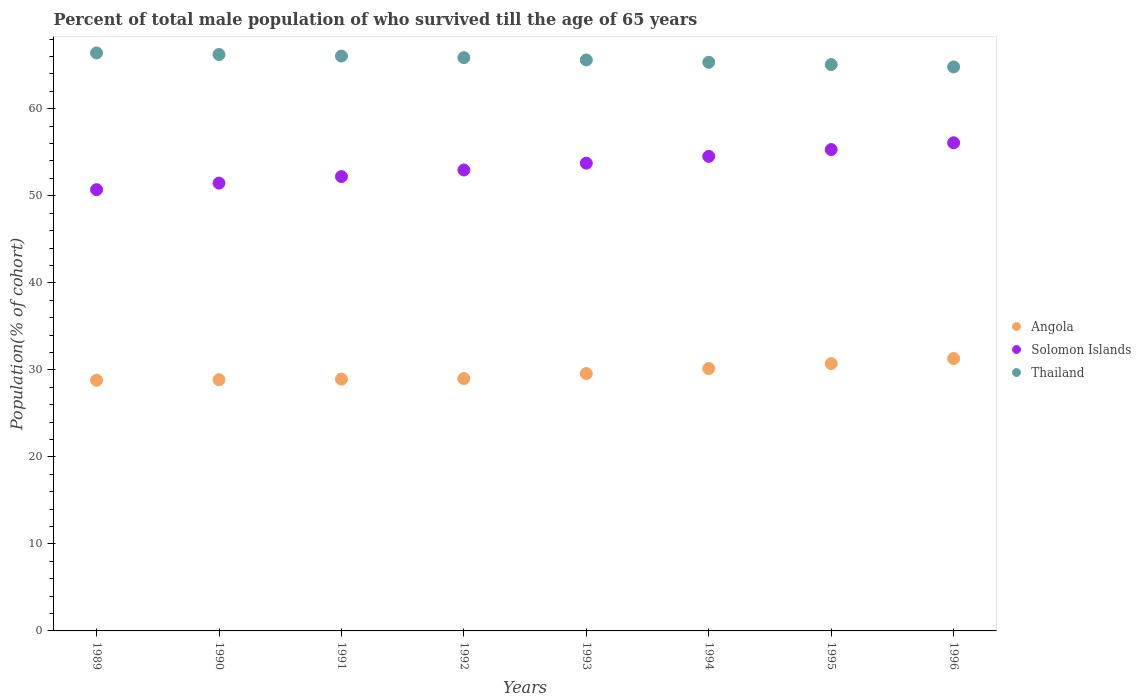Is the number of dotlines equal to the number of legend labels?
Ensure brevity in your answer.  Yes. What is the percentage of total male population who survived till the age of 65 years in Solomon Islands in 1993?
Give a very brief answer. 53.75. Across all years, what is the maximum percentage of total male population who survived till the age of 65 years in Angola?
Give a very brief answer. 31.3. Across all years, what is the minimum percentage of total male population who survived till the age of 65 years in Thailand?
Give a very brief answer. 64.81. In which year was the percentage of total male population who survived till the age of 65 years in Thailand maximum?
Keep it short and to the point. 1989. In which year was the percentage of total male population who survived till the age of 65 years in Thailand minimum?
Provide a succinct answer. 1996. What is the total percentage of total male population who survived till the age of 65 years in Solomon Islands in the graph?
Your answer should be compact. 427.02. What is the difference between the percentage of total male population who survived till the age of 65 years in Angola in 1991 and that in 1994?
Offer a terse response. -1.22. What is the difference between the percentage of total male population who survived till the age of 65 years in Solomon Islands in 1991 and the percentage of total male population who survived till the age of 65 years in Angola in 1996?
Ensure brevity in your answer.  20.91. What is the average percentage of total male population who survived till the age of 65 years in Solomon Islands per year?
Give a very brief answer. 53.38. In the year 1994, what is the difference between the percentage of total male population who survived till the age of 65 years in Thailand and percentage of total male population who survived till the age of 65 years in Angola?
Your response must be concise. 35.19. What is the ratio of the percentage of total male population who survived till the age of 65 years in Angola in 1989 to that in 1990?
Your response must be concise. 1. Is the percentage of total male population who survived till the age of 65 years in Angola in 1989 less than that in 1994?
Ensure brevity in your answer.  Yes. What is the difference between the highest and the second highest percentage of total male population who survived till the age of 65 years in Thailand?
Provide a short and direct response. 0.18. What is the difference between the highest and the lowest percentage of total male population who survived till the age of 65 years in Solomon Islands?
Provide a short and direct response. 5.39. In how many years, is the percentage of total male population who survived till the age of 65 years in Thailand greater than the average percentage of total male population who survived till the age of 65 years in Thailand taken over all years?
Your answer should be compact. 4. Does the percentage of total male population who survived till the age of 65 years in Solomon Islands monotonically increase over the years?
Keep it short and to the point. Yes. Is the percentage of total male population who survived till the age of 65 years in Angola strictly greater than the percentage of total male population who survived till the age of 65 years in Solomon Islands over the years?
Provide a succinct answer. No. What is the difference between two consecutive major ticks on the Y-axis?
Your response must be concise. 10. Does the graph contain any zero values?
Offer a terse response. No. Where does the legend appear in the graph?
Provide a short and direct response. Center right. How are the legend labels stacked?
Keep it short and to the point. Vertical. What is the title of the graph?
Your answer should be very brief. Percent of total male population of who survived till the age of 65 years. Does "Liechtenstein" appear as one of the legend labels in the graph?
Your response must be concise. No. What is the label or title of the X-axis?
Provide a short and direct response. Years. What is the label or title of the Y-axis?
Provide a short and direct response. Population(% of cohort). What is the Population(% of cohort) in Angola in 1989?
Your response must be concise. 28.81. What is the Population(% of cohort) of Solomon Islands in 1989?
Your response must be concise. 50.7. What is the Population(% of cohort) of Thailand in 1989?
Offer a very short reply. 66.41. What is the Population(% of cohort) in Angola in 1990?
Your response must be concise. 28.87. What is the Population(% of cohort) in Solomon Islands in 1990?
Offer a terse response. 51.46. What is the Population(% of cohort) in Thailand in 1990?
Offer a terse response. 66.23. What is the Population(% of cohort) in Angola in 1991?
Your answer should be compact. 28.93. What is the Population(% of cohort) in Solomon Islands in 1991?
Offer a very short reply. 52.21. What is the Population(% of cohort) in Thailand in 1991?
Your answer should be compact. 66.06. What is the Population(% of cohort) in Angola in 1992?
Your answer should be compact. 29. What is the Population(% of cohort) in Solomon Islands in 1992?
Give a very brief answer. 52.97. What is the Population(% of cohort) of Thailand in 1992?
Provide a succinct answer. 65.88. What is the Population(% of cohort) in Angola in 1993?
Keep it short and to the point. 29.57. What is the Population(% of cohort) of Solomon Islands in 1993?
Your answer should be compact. 53.75. What is the Population(% of cohort) of Thailand in 1993?
Offer a terse response. 65.61. What is the Population(% of cohort) of Angola in 1994?
Ensure brevity in your answer.  30.15. What is the Population(% of cohort) of Solomon Islands in 1994?
Provide a short and direct response. 54.53. What is the Population(% of cohort) in Thailand in 1994?
Give a very brief answer. 65.34. What is the Population(% of cohort) in Angola in 1995?
Give a very brief answer. 30.72. What is the Population(% of cohort) in Solomon Islands in 1995?
Provide a succinct answer. 55.31. What is the Population(% of cohort) of Thailand in 1995?
Keep it short and to the point. 65.07. What is the Population(% of cohort) in Angola in 1996?
Make the answer very short. 31.3. What is the Population(% of cohort) in Solomon Islands in 1996?
Your answer should be compact. 56.09. What is the Population(% of cohort) of Thailand in 1996?
Ensure brevity in your answer.  64.81. Across all years, what is the maximum Population(% of cohort) of Angola?
Your answer should be compact. 31.3. Across all years, what is the maximum Population(% of cohort) of Solomon Islands?
Your answer should be compact. 56.09. Across all years, what is the maximum Population(% of cohort) of Thailand?
Offer a very short reply. 66.41. Across all years, what is the minimum Population(% of cohort) of Angola?
Provide a succinct answer. 28.81. Across all years, what is the minimum Population(% of cohort) in Solomon Islands?
Offer a terse response. 50.7. Across all years, what is the minimum Population(% of cohort) of Thailand?
Keep it short and to the point. 64.81. What is the total Population(% of cohort) of Angola in the graph?
Ensure brevity in your answer.  237.35. What is the total Population(% of cohort) of Solomon Islands in the graph?
Your response must be concise. 427.02. What is the total Population(% of cohort) of Thailand in the graph?
Make the answer very short. 525.41. What is the difference between the Population(% of cohort) of Angola in 1989 and that in 1990?
Offer a terse response. -0.06. What is the difference between the Population(% of cohort) of Solomon Islands in 1989 and that in 1990?
Make the answer very short. -0.75. What is the difference between the Population(% of cohort) of Thailand in 1989 and that in 1990?
Ensure brevity in your answer.  0.18. What is the difference between the Population(% of cohort) in Angola in 1989 and that in 1991?
Give a very brief answer. -0.13. What is the difference between the Population(% of cohort) of Solomon Islands in 1989 and that in 1991?
Ensure brevity in your answer.  -1.51. What is the difference between the Population(% of cohort) of Thailand in 1989 and that in 1991?
Ensure brevity in your answer.  0.36. What is the difference between the Population(% of cohort) in Angola in 1989 and that in 1992?
Make the answer very short. -0.19. What is the difference between the Population(% of cohort) in Solomon Islands in 1989 and that in 1992?
Offer a very short reply. -2.26. What is the difference between the Population(% of cohort) in Thailand in 1989 and that in 1992?
Your answer should be very brief. 0.54. What is the difference between the Population(% of cohort) of Angola in 1989 and that in 1993?
Make the answer very short. -0.77. What is the difference between the Population(% of cohort) in Solomon Islands in 1989 and that in 1993?
Your answer should be very brief. -3.05. What is the difference between the Population(% of cohort) in Thailand in 1989 and that in 1993?
Offer a very short reply. 0.81. What is the difference between the Population(% of cohort) in Angola in 1989 and that in 1994?
Your response must be concise. -1.34. What is the difference between the Population(% of cohort) of Solomon Islands in 1989 and that in 1994?
Your answer should be very brief. -3.83. What is the difference between the Population(% of cohort) in Thailand in 1989 and that in 1994?
Provide a short and direct response. 1.07. What is the difference between the Population(% of cohort) of Angola in 1989 and that in 1995?
Your answer should be very brief. -1.92. What is the difference between the Population(% of cohort) in Solomon Islands in 1989 and that in 1995?
Offer a terse response. -4.61. What is the difference between the Population(% of cohort) in Thailand in 1989 and that in 1995?
Your response must be concise. 1.34. What is the difference between the Population(% of cohort) of Angola in 1989 and that in 1996?
Keep it short and to the point. -2.5. What is the difference between the Population(% of cohort) of Solomon Islands in 1989 and that in 1996?
Your response must be concise. -5.39. What is the difference between the Population(% of cohort) of Thailand in 1989 and that in 1996?
Give a very brief answer. 1.61. What is the difference between the Population(% of cohort) in Angola in 1990 and that in 1991?
Offer a terse response. -0.06. What is the difference between the Population(% of cohort) of Solomon Islands in 1990 and that in 1991?
Your answer should be very brief. -0.75. What is the difference between the Population(% of cohort) of Thailand in 1990 and that in 1991?
Provide a succinct answer. 0.18. What is the difference between the Population(% of cohort) of Angola in 1990 and that in 1992?
Provide a short and direct response. -0.13. What is the difference between the Population(% of cohort) in Solomon Islands in 1990 and that in 1992?
Give a very brief answer. -1.51. What is the difference between the Population(% of cohort) of Thailand in 1990 and that in 1992?
Your answer should be very brief. 0.36. What is the difference between the Population(% of cohort) of Angola in 1990 and that in 1993?
Ensure brevity in your answer.  -0.7. What is the difference between the Population(% of cohort) of Solomon Islands in 1990 and that in 1993?
Provide a succinct answer. -2.29. What is the difference between the Population(% of cohort) in Thailand in 1990 and that in 1993?
Provide a succinct answer. 0.63. What is the difference between the Population(% of cohort) in Angola in 1990 and that in 1994?
Ensure brevity in your answer.  -1.28. What is the difference between the Population(% of cohort) of Solomon Islands in 1990 and that in 1994?
Your answer should be compact. -3.07. What is the difference between the Population(% of cohort) of Thailand in 1990 and that in 1994?
Give a very brief answer. 0.89. What is the difference between the Population(% of cohort) of Angola in 1990 and that in 1995?
Offer a very short reply. -1.86. What is the difference between the Population(% of cohort) of Solomon Islands in 1990 and that in 1995?
Make the answer very short. -3.85. What is the difference between the Population(% of cohort) in Thailand in 1990 and that in 1995?
Your answer should be compact. 1.16. What is the difference between the Population(% of cohort) of Angola in 1990 and that in 1996?
Your answer should be very brief. -2.43. What is the difference between the Population(% of cohort) of Solomon Islands in 1990 and that in 1996?
Ensure brevity in your answer.  -4.64. What is the difference between the Population(% of cohort) of Thailand in 1990 and that in 1996?
Give a very brief answer. 1.43. What is the difference between the Population(% of cohort) of Angola in 1991 and that in 1992?
Offer a very short reply. -0.06. What is the difference between the Population(% of cohort) of Solomon Islands in 1991 and that in 1992?
Keep it short and to the point. -0.75. What is the difference between the Population(% of cohort) in Thailand in 1991 and that in 1992?
Offer a very short reply. 0.18. What is the difference between the Population(% of cohort) of Angola in 1991 and that in 1993?
Your response must be concise. -0.64. What is the difference between the Population(% of cohort) of Solomon Islands in 1991 and that in 1993?
Make the answer very short. -1.54. What is the difference between the Population(% of cohort) in Thailand in 1991 and that in 1993?
Your answer should be very brief. 0.45. What is the difference between the Population(% of cohort) of Angola in 1991 and that in 1994?
Your answer should be very brief. -1.22. What is the difference between the Population(% of cohort) in Solomon Islands in 1991 and that in 1994?
Make the answer very short. -2.32. What is the difference between the Population(% of cohort) of Thailand in 1991 and that in 1994?
Your answer should be compact. 0.71. What is the difference between the Population(% of cohort) of Angola in 1991 and that in 1995?
Your answer should be very brief. -1.79. What is the difference between the Population(% of cohort) in Solomon Islands in 1991 and that in 1995?
Give a very brief answer. -3.1. What is the difference between the Population(% of cohort) in Thailand in 1991 and that in 1995?
Keep it short and to the point. 0.98. What is the difference between the Population(% of cohort) of Angola in 1991 and that in 1996?
Provide a short and direct response. -2.37. What is the difference between the Population(% of cohort) in Solomon Islands in 1991 and that in 1996?
Your response must be concise. -3.88. What is the difference between the Population(% of cohort) in Thailand in 1991 and that in 1996?
Make the answer very short. 1.25. What is the difference between the Population(% of cohort) of Angola in 1992 and that in 1993?
Provide a short and direct response. -0.58. What is the difference between the Population(% of cohort) in Solomon Islands in 1992 and that in 1993?
Offer a very short reply. -0.78. What is the difference between the Population(% of cohort) in Thailand in 1992 and that in 1993?
Keep it short and to the point. 0.27. What is the difference between the Population(% of cohort) in Angola in 1992 and that in 1994?
Make the answer very short. -1.15. What is the difference between the Population(% of cohort) in Solomon Islands in 1992 and that in 1994?
Offer a very short reply. -1.56. What is the difference between the Population(% of cohort) in Thailand in 1992 and that in 1994?
Provide a succinct answer. 0.53. What is the difference between the Population(% of cohort) in Angola in 1992 and that in 1995?
Provide a short and direct response. -1.73. What is the difference between the Population(% of cohort) in Solomon Islands in 1992 and that in 1995?
Make the answer very short. -2.35. What is the difference between the Population(% of cohort) of Thailand in 1992 and that in 1995?
Keep it short and to the point. 0.8. What is the difference between the Population(% of cohort) of Angola in 1992 and that in 1996?
Your response must be concise. -2.31. What is the difference between the Population(% of cohort) in Solomon Islands in 1992 and that in 1996?
Keep it short and to the point. -3.13. What is the difference between the Population(% of cohort) in Thailand in 1992 and that in 1996?
Give a very brief answer. 1.07. What is the difference between the Population(% of cohort) of Angola in 1993 and that in 1994?
Offer a very short reply. -0.58. What is the difference between the Population(% of cohort) of Solomon Islands in 1993 and that in 1994?
Give a very brief answer. -0.78. What is the difference between the Population(% of cohort) in Thailand in 1993 and that in 1994?
Give a very brief answer. 0.27. What is the difference between the Population(% of cohort) in Angola in 1993 and that in 1995?
Offer a terse response. -1.15. What is the difference between the Population(% of cohort) of Solomon Islands in 1993 and that in 1995?
Ensure brevity in your answer.  -1.56. What is the difference between the Population(% of cohort) in Thailand in 1993 and that in 1995?
Provide a succinct answer. 0.53. What is the difference between the Population(% of cohort) in Angola in 1993 and that in 1996?
Provide a short and direct response. -1.73. What is the difference between the Population(% of cohort) of Solomon Islands in 1993 and that in 1996?
Provide a succinct answer. -2.35. What is the difference between the Population(% of cohort) in Thailand in 1993 and that in 1996?
Give a very brief answer. 0.8. What is the difference between the Population(% of cohort) in Angola in 1994 and that in 1995?
Give a very brief answer. -0.58. What is the difference between the Population(% of cohort) in Solomon Islands in 1994 and that in 1995?
Offer a very short reply. -0.78. What is the difference between the Population(% of cohort) of Thailand in 1994 and that in 1995?
Ensure brevity in your answer.  0.27. What is the difference between the Population(% of cohort) in Angola in 1994 and that in 1996?
Make the answer very short. -1.15. What is the difference between the Population(% of cohort) in Solomon Islands in 1994 and that in 1996?
Provide a succinct answer. -1.56. What is the difference between the Population(% of cohort) in Thailand in 1994 and that in 1996?
Keep it short and to the point. 0.53. What is the difference between the Population(% of cohort) in Angola in 1995 and that in 1996?
Keep it short and to the point. -0.58. What is the difference between the Population(% of cohort) in Solomon Islands in 1995 and that in 1996?
Make the answer very short. -0.78. What is the difference between the Population(% of cohort) in Thailand in 1995 and that in 1996?
Keep it short and to the point. 0.27. What is the difference between the Population(% of cohort) in Angola in 1989 and the Population(% of cohort) in Solomon Islands in 1990?
Your answer should be compact. -22.65. What is the difference between the Population(% of cohort) of Angola in 1989 and the Population(% of cohort) of Thailand in 1990?
Your response must be concise. -37.43. What is the difference between the Population(% of cohort) of Solomon Islands in 1989 and the Population(% of cohort) of Thailand in 1990?
Your answer should be very brief. -15.53. What is the difference between the Population(% of cohort) of Angola in 1989 and the Population(% of cohort) of Solomon Islands in 1991?
Your answer should be very brief. -23.41. What is the difference between the Population(% of cohort) in Angola in 1989 and the Population(% of cohort) in Thailand in 1991?
Make the answer very short. -37.25. What is the difference between the Population(% of cohort) in Solomon Islands in 1989 and the Population(% of cohort) in Thailand in 1991?
Provide a short and direct response. -15.35. What is the difference between the Population(% of cohort) in Angola in 1989 and the Population(% of cohort) in Solomon Islands in 1992?
Offer a terse response. -24.16. What is the difference between the Population(% of cohort) of Angola in 1989 and the Population(% of cohort) of Thailand in 1992?
Offer a very short reply. -37.07. What is the difference between the Population(% of cohort) in Solomon Islands in 1989 and the Population(% of cohort) in Thailand in 1992?
Make the answer very short. -15.17. What is the difference between the Population(% of cohort) in Angola in 1989 and the Population(% of cohort) in Solomon Islands in 1993?
Give a very brief answer. -24.94. What is the difference between the Population(% of cohort) of Angola in 1989 and the Population(% of cohort) of Thailand in 1993?
Provide a succinct answer. -36.8. What is the difference between the Population(% of cohort) of Solomon Islands in 1989 and the Population(% of cohort) of Thailand in 1993?
Your answer should be very brief. -14.91. What is the difference between the Population(% of cohort) in Angola in 1989 and the Population(% of cohort) in Solomon Islands in 1994?
Provide a short and direct response. -25.72. What is the difference between the Population(% of cohort) of Angola in 1989 and the Population(% of cohort) of Thailand in 1994?
Offer a very short reply. -36.54. What is the difference between the Population(% of cohort) of Solomon Islands in 1989 and the Population(% of cohort) of Thailand in 1994?
Offer a terse response. -14.64. What is the difference between the Population(% of cohort) of Angola in 1989 and the Population(% of cohort) of Solomon Islands in 1995?
Give a very brief answer. -26.51. What is the difference between the Population(% of cohort) in Angola in 1989 and the Population(% of cohort) in Thailand in 1995?
Your response must be concise. -36.27. What is the difference between the Population(% of cohort) of Solomon Islands in 1989 and the Population(% of cohort) of Thailand in 1995?
Your answer should be compact. -14.37. What is the difference between the Population(% of cohort) of Angola in 1989 and the Population(% of cohort) of Solomon Islands in 1996?
Your response must be concise. -27.29. What is the difference between the Population(% of cohort) of Angola in 1989 and the Population(% of cohort) of Thailand in 1996?
Ensure brevity in your answer.  -36. What is the difference between the Population(% of cohort) in Solomon Islands in 1989 and the Population(% of cohort) in Thailand in 1996?
Your answer should be very brief. -14.1. What is the difference between the Population(% of cohort) of Angola in 1990 and the Population(% of cohort) of Solomon Islands in 1991?
Offer a very short reply. -23.34. What is the difference between the Population(% of cohort) in Angola in 1990 and the Population(% of cohort) in Thailand in 1991?
Provide a succinct answer. -37.19. What is the difference between the Population(% of cohort) in Solomon Islands in 1990 and the Population(% of cohort) in Thailand in 1991?
Offer a terse response. -14.6. What is the difference between the Population(% of cohort) of Angola in 1990 and the Population(% of cohort) of Solomon Islands in 1992?
Your response must be concise. -24.1. What is the difference between the Population(% of cohort) in Angola in 1990 and the Population(% of cohort) in Thailand in 1992?
Your answer should be very brief. -37.01. What is the difference between the Population(% of cohort) of Solomon Islands in 1990 and the Population(% of cohort) of Thailand in 1992?
Your response must be concise. -14.42. What is the difference between the Population(% of cohort) in Angola in 1990 and the Population(% of cohort) in Solomon Islands in 1993?
Give a very brief answer. -24.88. What is the difference between the Population(% of cohort) in Angola in 1990 and the Population(% of cohort) in Thailand in 1993?
Keep it short and to the point. -36.74. What is the difference between the Population(% of cohort) in Solomon Islands in 1990 and the Population(% of cohort) in Thailand in 1993?
Your response must be concise. -14.15. What is the difference between the Population(% of cohort) of Angola in 1990 and the Population(% of cohort) of Solomon Islands in 1994?
Provide a succinct answer. -25.66. What is the difference between the Population(% of cohort) of Angola in 1990 and the Population(% of cohort) of Thailand in 1994?
Give a very brief answer. -36.47. What is the difference between the Population(% of cohort) of Solomon Islands in 1990 and the Population(% of cohort) of Thailand in 1994?
Provide a short and direct response. -13.88. What is the difference between the Population(% of cohort) of Angola in 1990 and the Population(% of cohort) of Solomon Islands in 1995?
Your answer should be compact. -26.44. What is the difference between the Population(% of cohort) of Angola in 1990 and the Population(% of cohort) of Thailand in 1995?
Give a very brief answer. -36.21. What is the difference between the Population(% of cohort) in Solomon Islands in 1990 and the Population(% of cohort) in Thailand in 1995?
Provide a short and direct response. -13.62. What is the difference between the Population(% of cohort) in Angola in 1990 and the Population(% of cohort) in Solomon Islands in 1996?
Keep it short and to the point. -27.22. What is the difference between the Population(% of cohort) of Angola in 1990 and the Population(% of cohort) of Thailand in 1996?
Keep it short and to the point. -35.94. What is the difference between the Population(% of cohort) in Solomon Islands in 1990 and the Population(% of cohort) in Thailand in 1996?
Offer a terse response. -13.35. What is the difference between the Population(% of cohort) in Angola in 1991 and the Population(% of cohort) in Solomon Islands in 1992?
Your response must be concise. -24.03. What is the difference between the Population(% of cohort) in Angola in 1991 and the Population(% of cohort) in Thailand in 1992?
Provide a succinct answer. -36.94. What is the difference between the Population(% of cohort) in Solomon Islands in 1991 and the Population(% of cohort) in Thailand in 1992?
Keep it short and to the point. -13.66. What is the difference between the Population(% of cohort) of Angola in 1991 and the Population(% of cohort) of Solomon Islands in 1993?
Give a very brief answer. -24.82. What is the difference between the Population(% of cohort) in Angola in 1991 and the Population(% of cohort) in Thailand in 1993?
Give a very brief answer. -36.68. What is the difference between the Population(% of cohort) of Solomon Islands in 1991 and the Population(% of cohort) of Thailand in 1993?
Offer a terse response. -13.4. What is the difference between the Population(% of cohort) in Angola in 1991 and the Population(% of cohort) in Solomon Islands in 1994?
Your answer should be compact. -25.6. What is the difference between the Population(% of cohort) of Angola in 1991 and the Population(% of cohort) of Thailand in 1994?
Make the answer very short. -36.41. What is the difference between the Population(% of cohort) of Solomon Islands in 1991 and the Population(% of cohort) of Thailand in 1994?
Ensure brevity in your answer.  -13.13. What is the difference between the Population(% of cohort) of Angola in 1991 and the Population(% of cohort) of Solomon Islands in 1995?
Make the answer very short. -26.38. What is the difference between the Population(% of cohort) in Angola in 1991 and the Population(% of cohort) in Thailand in 1995?
Your answer should be compact. -36.14. What is the difference between the Population(% of cohort) of Solomon Islands in 1991 and the Population(% of cohort) of Thailand in 1995?
Your response must be concise. -12.86. What is the difference between the Population(% of cohort) in Angola in 1991 and the Population(% of cohort) in Solomon Islands in 1996?
Your response must be concise. -27.16. What is the difference between the Population(% of cohort) of Angola in 1991 and the Population(% of cohort) of Thailand in 1996?
Provide a short and direct response. -35.87. What is the difference between the Population(% of cohort) of Solomon Islands in 1991 and the Population(% of cohort) of Thailand in 1996?
Your answer should be very brief. -12.6. What is the difference between the Population(% of cohort) of Angola in 1992 and the Population(% of cohort) of Solomon Islands in 1993?
Ensure brevity in your answer.  -24.75. What is the difference between the Population(% of cohort) in Angola in 1992 and the Population(% of cohort) in Thailand in 1993?
Your answer should be compact. -36.61. What is the difference between the Population(% of cohort) of Solomon Islands in 1992 and the Population(% of cohort) of Thailand in 1993?
Offer a terse response. -12.64. What is the difference between the Population(% of cohort) of Angola in 1992 and the Population(% of cohort) of Solomon Islands in 1994?
Your response must be concise. -25.53. What is the difference between the Population(% of cohort) of Angola in 1992 and the Population(% of cohort) of Thailand in 1994?
Give a very brief answer. -36.35. What is the difference between the Population(% of cohort) of Solomon Islands in 1992 and the Population(% of cohort) of Thailand in 1994?
Your answer should be very brief. -12.38. What is the difference between the Population(% of cohort) of Angola in 1992 and the Population(% of cohort) of Solomon Islands in 1995?
Provide a succinct answer. -26.32. What is the difference between the Population(% of cohort) of Angola in 1992 and the Population(% of cohort) of Thailand in 1995?
Your answer should be very brief. -36.08. What is the difference between the Population(% of cohort) in Solomon Islands in 1992 and the Population(% of cohort) in Thailand in 1995?
Provide a succinct answer. -12.11. What is the difference between the Population(% of cohort) in Angola in 1992 and the Population(% of cohort) in Solomon Islands in 1996?
Offer a terse response. -27.1. What is the difference between the Population(% of cohort) of Angola in 1992 and the Population(% of cohort) of Thailand in 1996?
Your response must be concise. -35.81. What is the difference between the Population(% of cohort) of Solomon Islands in 1992 and the Population(% of cohort) of Thailand in 1996?
Offer a terse response. -11.84. What is the difference between the Population(% of cohort) of Angola in 1993 and the Population(% of cohort) of Solomon Islands in 1994?
Give a very brief answer. -24.96. What is the difference between the Population(% of cohort) of Angola in 1993 and the Population(% of cohort) of Thailand in 1994?
Provide a short and direct response. -35.77. What is the difference between the Population(% of cohort) of Solomon Islands in 1993 and the Population(% of cohort) of Thailand in 1994?
Keep it short and to the point. -11.59. What is the difference between the Population(% of cohort) in Angola in 1993 and the Population(% of cohort) in Solomon Islands in 1995?
Your answer should be very brief. -25.74. What is the difference between the Population(% of cohort) in Angola in 1993 and the Population(% of cohort) in Thailand in 1995?
Make the answer very short. -35.5. What is the difference between the Population(% of cohort) of Solomon Islands in 1993 and the Population(% of cohort) of Thailand in 1995?
Keep it short and to the point. -11.33. What is the difference between the Population(% of cohort) of Angola in 1993 and the Population(% of cohort) of Solomon Islands in 1996?
Make the answer very short. -26.52. What is the difference between the Population(% of cohort) of Angola in 1993 and the Population(% of cohort) of Thailand in 1996?
Provide a short and direct response. -35.24. What is the difference between the Population(% of cohort) in Solomon Islands in 1993 and the Population(% of cohort) in Thailand in 1996?
Provide a short and direct response. -11.06. What is the difference between the Population(% of cohort) of Angola in 1994 and the Population(% of cohort) of Solomon Islands in 1995?
Your response must be concise. -25.16. What is the difference between the Population(% of cohort) of Angola in 1994 and the Population(% of cohort) of Thailand in 1995?
Offer a very short reply. -34.93. What is the difference between the Population(% of cohort) in Solomon Islands in 1994 and the Population(% of cohort) in Thailand in 1995?
Provide a succinct answer. -10.54. What is the difference between the Population(% of cohort) of Angola in 1994 and the Population(% of cohort) of Solomon Islands in 1996?
Your answer should be compact. -25.94. What is the difference between the Population(% of cohort) of Angola in 1994 and the Population(% of cohort) of Thailand in 1996?
Ensure brevity in your answer.  -34.66. What is the difference between the Population(% of cohort) in Solomon Islands in 1994 and the Population(% of cohort) in Thailand in 1996?
Offer a very short reply. -10.28. What is the difference between the Population(% of cohort) in Angola in 1995 and the Population(% of cohort) in Solomon Islands in 1996?
Offer a terse response. -25.37. What is the difference between the Population(% of cohort) in Angola in 1995 and the Population(% of cohort) in Thailand in 1996?
Offer a very short reply. -34.08. What is the difference between the Population(% of cohort) of Solomon Islands in 1995 and the Population(% of cohort) of Thailand in 1996?
Your answer should be compact. -9.5. What is the average Population(% of cohort) in Angola per year?
Offer a terse response. 29.67. What is the average Population(% of cohort) in Solomon Islands per year?
Offer a very short reply. 53.38. What is the average Population(% of cohort) in Thailand per year?
Your response must be concise. 65.68. In the year 1989, what is the difference between the Population(% of cohort) in Angola and Population(% of cohort) in Solomon Islands?
Give a very brief answer. -21.9. In the year 1989, what is the difference between the Population(% of cohort) in Angola and Population(% of cohort) in Thailand?
Ensure brevity in your answer.  -37.61. In the year 1989, what is the difference between the Population(% of cohort) of Solomon Islands and Population(% of cohort) of Thailand?
Ensure brevity in your answer.  -15.71. In the year 1990, what is the difference between the Population(% of cohort) in Angola and Population(% of cohort) in Solomon Islands?
Provide a succinct answer. -22.59. In the year 1990, what is the difference between the Population(% of cohort) in Angola and Population(% of cohort) in Thailand?
Your response must be concise. -37.37. In the year 1990, what is the difference between the Population(% of cohort) of Solomon Islands and Population(% of cohort) of Thailand?
Provide a short and direct response. -14.78. In the year 1991, what is the difference between the Population(% of cohort) in Angola and Population(% of cohort) in Solomon Islands?
Offer a terse response. -23.28. In the year 1991, what is the difference between the Population(% of cohort) of Angola and Population(% of cohort) of Thailand?
Give a very brief answer. -37.12. In the year 1991, what is the difference between the Population(% of cohort) of Solomon Islands and Population(% of cohort) of Thailand?
Ensure brevity in your answer.  -13.84. In the year 1992, what is the difference between the Population(% of cohort) of Angola and Population(% of cohort) of Solomon Islands?
Make the answer very short. -23.97. In the year 1992, what is the difference between the Population(% of cohort) of Angola and Population(% of cohort) of Thailand?
Your answer should be very brief. -36.88. In the year 1992, what is the difference between the Population(% of cohort) in Solomon Islands and Population(% of cohort) in Thailand?
Ensure brevity in your answer.  -12.91. In the year 1993, what is the difference between the Population(% of cohort) in Angola and Population(% of cohort) in Solomon Islands?
Your response must be concise. -24.18. In the year 1993, what is the difference between the Population(% of cohort) in Angola and Population(% of cohort) in Thailand?
Keep it short and to the point. -36.04. In the year 1993, what is the difference between the Population(% of cohort) of Solomon Islands and Population(% of cohort) of Thailand?
Give a very brief answer. -11.86. In the year 1994, what is the difference between the Population(% of cohort) of Angola and Population(% of cohort) of Solomon Islands?
Give a very brief answer. -24.38. In the year 1994, what is the difference between the Population(% of cohort) in Angola and Population(% of cohort) in Thailand?
Your answer should be compact. -35.19. In the year 1994, what is the difference between the Population(% of cohort) in Solomon Islands and Population(% of cohort) in Thailand?
Ensure brevity in your answer.  -10.81. In the year 1995, what is the difference between the Population(% of cohort) in Angola and Population(% of cohort) in Solomon Islands?
Make the answer very short. -24.59. In the year 1995, what is the difference between the Population(% of cohort) of Angola and Population(% of cohort) of Thailand?
Offer a terse response. -34.35. In the year 1995, what is the difference between the Population(% of cohort) of Solomon Islands and Population(% of cohort) of Thailand?
Give a very brief answer. -9.76. In the year 1996, what is the difference between the Population(% of cohort) in Angola and Population(% of cohort) in Solomon Islands?
Ensure brevity in your answer.  -24.79. In the year 1996, what is the difference between the Population(% of cohort) in Angola and Population(% of cohort) in Thailand?
Ensure brevity in your answer.  -33.51. In the year 1996, what is the difference between the Population(% of cohort) in Solomon Islands and Population(% of cohort) in Thailand?
Provide a succinct answer. -8.71. What is the ratio of the Population(% of cohort) in Solomon Islands in 1989 to that in 1990?
Provide a succinct answer. 0.99. What is the ratio of the Population(% of cohort) in Solomon Islands in 1989 to that in 1991?
Ensure brevity in your answer.  0.97. What is the ratio of the Population(% of cohort) of Thailand in 1989 to that in 1991?
Your response must be concise. 1.01. What is the ratio of the Population(% of cohort) in Solomon Islands in 1989 to that in 1992?
Provide a succinct answer. 0.96. What is the ratio of the Population(% of cohort) in Thailand in 1989 to that in 1992?
Provide a succinct answer. 1.01. What is the ratio of the Population(% of cohort) in Angola in 1989 to that in 1993?
Provide a short and direct response. 0.97. What is the ratio of the Population(% of cohort) in Solomon Islands in 1989 to that in 1993?
Provide a succinct answer. 0.94. What is the ratio of the Population(% of cohort) of Thailand in 1989 to that in 1993?
Give a very brief answer. 1.01. What is the ratio of the Population(% of cohort) in Angola in 1989 to that in 1994?
Offer a very short reply. 0.96. What is the ratio of the Population(% of cohort) in Solomon Islands in 1989 to that in 1994?
Offer a terse response. 0.93. What is the ratio of the Population(% of cohort) in Thailand in 1989 to that in 1994?
Offer a terse response. 1.02. What is the ratio of the Population(% of cohort) in Thailand in 1989 to that in 1995?
Ensure brevity in your answer.  1.02. What is the ratio of the Population(% of cohort) of Angola in 1989 to that in 1996?
Give a very brief answer. 0.92. What is the ratio of the Population(% of cohort) of Solomon Islands in 1989 to that in 1996?
Make the answer very short. 0.9. What is the ratio of the Population(% of cohort) in Thailand in 1989 to that in 1996?
Your response must be concise. 1.02. What is the ratio of the Population(% of cohort) in Angola in 1990 to that in 1991?
Your response must be concise. 1. What is the ratio of the Population(% of cohort) in Solomon Islands in 1990 to that in 1991?
Your response must be concise. 0.99. What is the ratio of the Population(% of cohort) of Solomon Islands in 1990 to that in 1992?
Your answer should be compact. 0.97. What is the ratio of the Population(% of cohort) in Angola in 1990 to that in 1993?
Give a very brief answer. 0.98. What is the ratio of the Population(% of cohort) in Solomon Islands in 1990 to that in 1993?
Your answer should be very brief. 0.96. What is the ratio of the Population(% of cohort) of Thailand in 1990 to that in 1993?
Your answer should be very brief. 1.01. What is the ratio of the Population(% of cohort) of Angola in 1990 to that in 1994?
Ensure brevity in your answer.  0.96. What is the ratio of the Population(% of cohort) in Solomon Islands in 1990 to that in 1994?
Offer a very short reply. 0.94. What is the ratio of the Population(% of cohort) in Thailand in 1990 to that in 1994?
Offer a terse response. 1.01. What is the ratio of the Population(% of cohort) of Angola in 1990 to that in 1995?
Ensure brevity in your answer.  0.94. What is the ratio of the Population(% of cohort) of Solomon Islands in 1990 to that in 1995?
Ensure brevity in your answer.  0.93. What is the ratio of the Population(% of cohort) of Thailand in 1990 to that in 1995?
Offer a terse response. 1.02. What is the ratio of the Population(% of cohort) in Angola in 1990 to that in 1996?
Ensure brevity in your answer.  0.92. What is the ratio of the Population(% of cohort) of Solomon Islands in 1990 to that in 1996?
Your response must be concise. 0.92. What is the ratio of the Population(% of cohort) of Angola in 1991 to that in 1992?
Give a very brief answer. 1. What is the ratio of the Population(% of cohort) of Solomon Islands in 1991 to that in 1992?
Ensure brevity in your answer.  0.99. What is the ratio of the Population(% of cohort) of Angola in 1991 to that in 1993?
Keep it short and to the point. 0.98. What is the ratio of the Population(% of cohort) of Solomon Islands in 1991 to that in 1993?
Make the answer very short. 0.97. What is the ratio of the Population(% of cohort) of Thailand in 1991 to that in 1993?
Offer a terse response. 1.01. What is the ratio of the Population(% of cohort) of Angola in 1991 to that in 1994?
Offer a very short reply. 0.96. What is the ratio of the Population(% of cohort) in Solomon Islands in 1991 to that in 1994?
Give a very brief answer. 0.96. What is the ratio of the Population(% of cohort) in Thailand in 1991 to that in 1994?
Your response must be concise. 1.01. What is the ratio of the Population(% of cohort) of Angola in 1991 to that in 1995?
Your answer should be compact. 0.94. What is the ratio of the Population(% of cohort) of Solomon Islands in 1991 to that in 1995?
Make the answer very short. 0.94. What is the ratio of the Population(% of cohort) of Thailand in 1991 to that in 1995?
Ensure brevity in your answer.  1.02. What is the ratio of the Population(% of cohort) of Angola in 1991 to that in 1996?
Your answer should be compact. 0.92. What is the ratio of the Population(% of cohort) in Solomon Islands in 1991 to that in 1996?
Give a very brief answer. 0.93. What is the ratio of the Population(% of cohort) in Thailand in 1991 to that in 1996?
Offer a terse response. 1.02. What is the ratio of the Population(% of cohort) of Angola in 1992 to that in 1993?
Your answer should be very brief. 0.98. What is the ratio of the Population(% of cohort) in Solomon Islands in 1992 to that in 1993?
Your answer should be very brief. 0.99. What is the ratio of the Population(% of cohort) of Thailand in 1992 to that in 1993?
Keep it short and to the point. 1. What is the ratio of the Population(% of cohort) in Angola in 1992 to that in 1994?
Your response must be concise. 0.96. What is the ratio of the Population(% of cohort) in Solomon Islands in 1992 to that in 1994?
Make the answer very short. 0.97. What is the ratio of the Population(% of cohort) in Thailand in 1992 to that in 1994?
Provide a succinct answer. 1.01. What is the ratio of the Population(% of cohort) in Angola in 1992 to that in 1995?
Ensure brevity in your answer.  0.94. What is the ratio of the Population(% of cohort) of Solomon Islands in 1992 to that in 1995?
Your response must be concise. 0.96. What is the ratio of the Population(% of cohort) of Thailand in 1992 to that in 1995?
Your answer should be compact. 1.01. What is the ratio of the Population(% of cohort) in Angola in 1992 to that in 1996?
Your answer should be compact. 0.93. What is the ratio of the Population(% of cohort) in Solomon Islands in 1992 to that in 1996?
Offer a terse response. 0.94. What is the ratio of the Population(% of cohort) of Thailand in 1992 to that in 1996?
Give a very brief answer. 1.02. What is the ratio of the Population(% of cohort) in Angola in 1993 to that in 1994?
Your answer should be compact. 0.98. What is the ratio of the Population(% of cohort) in Solomon Islands in 1993 to that in 1994?
Give a very brief answer. 0.99. What is the ratio of the Population(% of cohort) in Thailand in 1993 to that in 1994?
Give a very brief answer. 1. What is the ratio of the Population(% of cohort) in Angola in 1993 to that in 1995?
Your answer should be very brief. 0.96. What is the ratio of the Population(% of cohort) of Solomon Islands in 1993 to that in 1995?
Make the answer very short. 0.97. What is the ratio of the Population(% of cohort) in Thailand in 1993 to that in 1995?
Provide a short and direct response. 1.01. What is the ratio of the Population(% of cohort) in Angola in 1993 to that in 1996?
Give a very brief answer. 0.94. What is the ratio of the Population(% of cohort) in Solomon Islands in 1993 to that in 1996?
Provide a short and direct response. 0.96. What is the ratio of the Population(% of cohort) of Thailand in 1993 to that in 1996?
Offer a very short reply. 1.01. What is the ratio of the Population(% of cohort) in Angola in 1994 to that in 1995?
Offer a very short reply. 0.98. What is the ratio of the Population(% of cohort) of Solomon Islands in 1994 to that in 1995?
Your answer should be very brief. 0.99. What is the ratio of the Population(% of cohort) in Thailand in 1994 to that in 1995?
Provide a short and direct response. 1. What is the ratio of the Population(% of cohort) of Angola in 1994 to that in 1996?
Give a very brief answer. 0.96. What is the ratio of the Population(% of cohort) in Solomon Islands in 1994 to that in 1996?
Your response must be concise. 0.97. What is the ratio of the Population(% of cohort) of Thailand in 1994 to that in 1996?
Offer a very short reply. 1.01. What is the ratio of the Population(% of cohort) of Angola in 1995 to that in 1996?
Ensure brevity in your answer.  0.98. What is the ratio of the Population(% of cohort) of Solomon Islands in 1995 to that in 1996?
Your answer should be compact. 0.99. What is the ratio of the Population(% of cohort) in Thailand in 1995 to that in 1996?
Your answer should be compact. 1. What is the difference between the highest and the second highest Population(% of cohort) in Angola?
Ensure brevity in your answer.  0.58. What is the difference between the highest and the second highest Population(% of cohort) in Solomon Islands?
Your answer should be very brief. 0.78. What is the difference between the highest and the second highest Population(% of cohort) of Thailand?
Give a very brief answer. 0.18. What is the difference between the highest and the lowest Population(% of cohort) of Angola?
Provide a short and direct response. 2.5. What is the difference between the highest and the lowest Population(% of cohort) of Solomon Islands?
Provide a succinct answer. 5.39. What is the difference between the highest and the lowest Population(% of cohort) in Thailand?
Offer a very short reply. 1.61. 